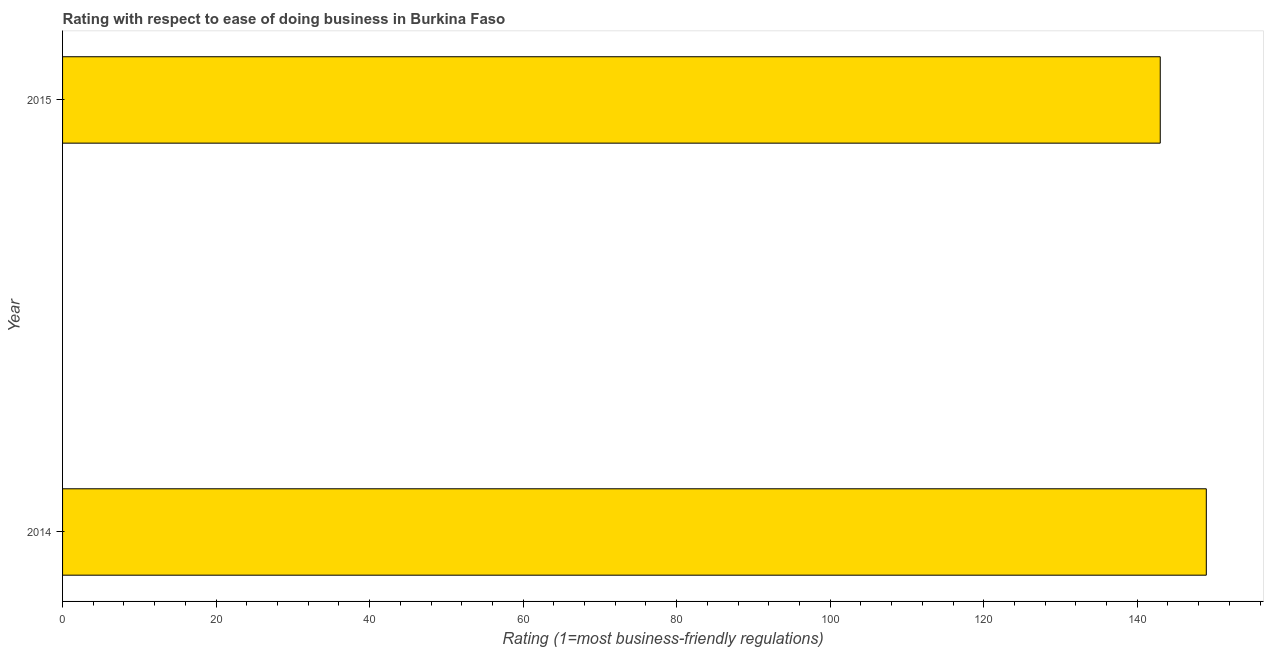Does the graph contain grids?
Ensure brevity in your answer.  No. What is the title of the graph?
Offer a terse response. Rating with respect to ease of doing business in Burkina Faso. What is the label or title of the X-axis?
Provide a succinct answer. Rating (1=most business-friendly regulations). What is the ease of doing business index in 2015?
Keep it short and to the point. 143. Across all years, what is the maximum ease of doing business index?
Offer a very short reply. 149. Across all years, what is the minimum ease of doing business index?
Offer a terse response. 143. In which year was the ease of doing business index minimum?
Ensure brevity in your answer.  2015. What is the sum of the ease of doing business index?
Offer a terse response. 292. What is the average ease of doing business index per year?
Provide a short and direct response. 146. What is the median ease of doing business index?
Offer a very short reply. 146. In how many years, is the ease of doing business index greater than 132 ?
Keep it short and to the point. 2. What is the ratio of the ease of doing business index in 2014 to that in 2015?
Keep it short and to the point. 1.04. Is the ease of doing business index in 2014 less than that in 2015?
Make the answer very short. No. In how many years, is the ease of doing business index greater than the average ease of doing business index taken over all years?
Offer a very short reply. 1. How many bars are there?
Provide a succinct answer. 2. Are all the bars in the graph horizontal?
Give a very brief answer. Yes. What is the difference between two consecutive major ticks on the X-axis?
Your response must be concise. 20. Are the values on the major ticks of X-axis written in scientific E-notation?
Keep it short and to the point. No. What is the Rating (1=most business-friendly regulations) of 2014?
Provide a short and direct response. 149. What is the Rating (1=most business-friendly regulations) of 2015?
Keep it short and to the point. 143. What is the ratio of the Rating (1=most business-friendly regulations) in 2014 to that in 2015?
Your response must be concise. 1.04. 